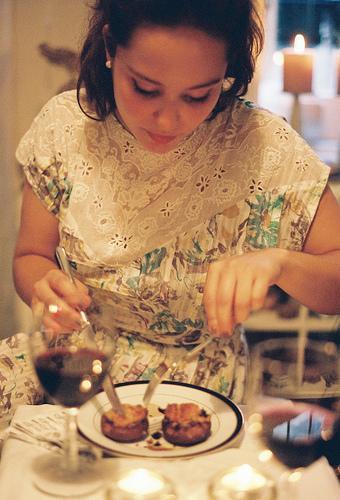How many items are on plate?
Give a very brief answer. 2. How many people are in photo?
Give a very brief answer. 1. 